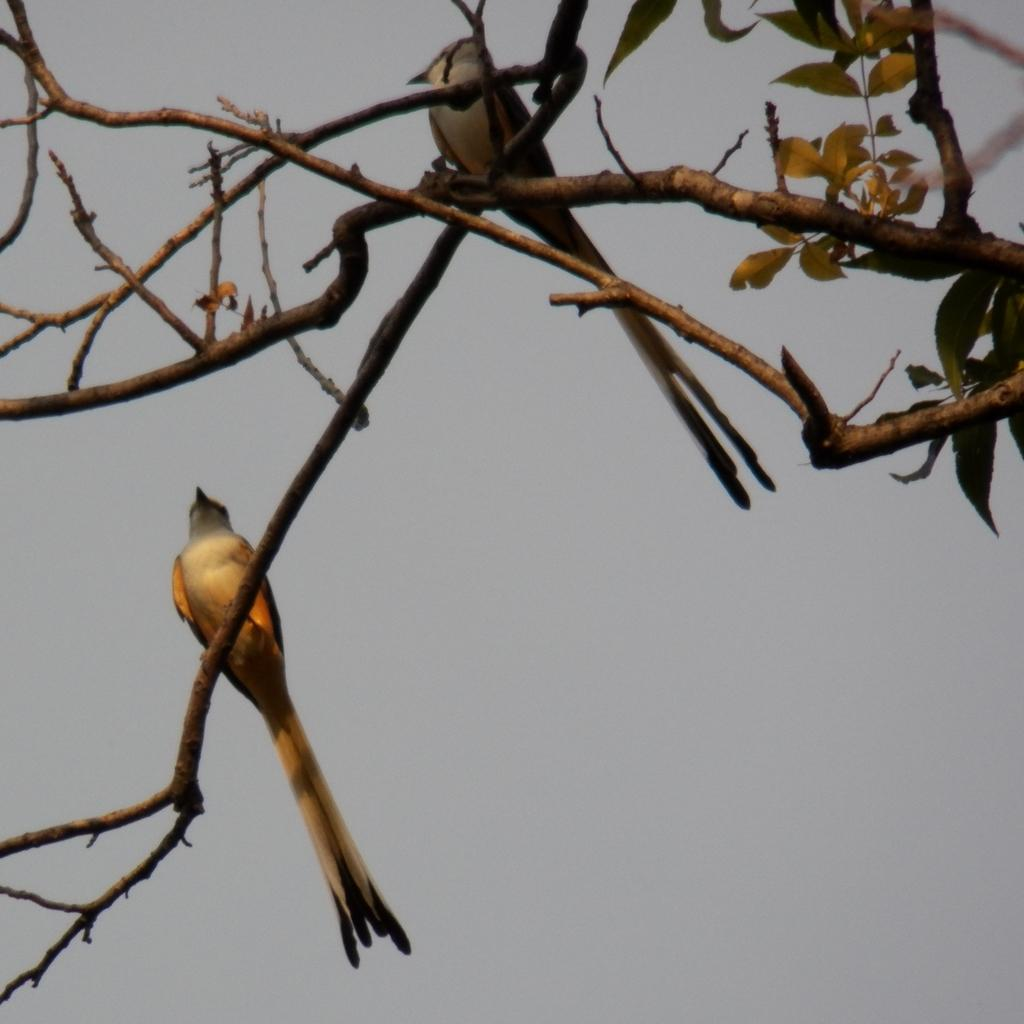How many birds are present in the image? There are two birds in the image. What are the birds sitting on? The birds are sitting on stems. What can be seen on the stems? The stems have leaves. What is visible in the background of the image? The sky is visible in the background of the image. What type of bun is the bird holding in its beak in the image? There is no bun present in the image; the birds are sitting on stems with leaves. Are the birds saying good-bye to each other in the image? There is no indication in the image that the birds are saying good-bye to each other. 